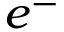Convert formula to latex. <formula><loc_0><loc_0><loc_500><loc_500>e ^ { - }</formula> 